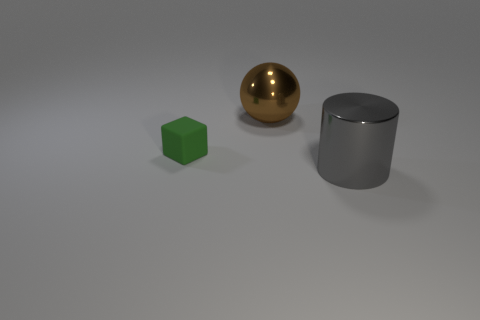Add 1 red metal cubes. How many objects exist? 4 Subtract all spheres. How many objects are left? 2 Subtract 0 blue spheres. How many objects are left? 3 Subtract all large shiny cylinders. Subtract all tiny blue things. How many objects are left? 2 Add 3 large brown metal balls. How many large brown metal balls are left? 4 Add 1 big blue matte cylinders. How many big blue matte cylinders exist? 1 